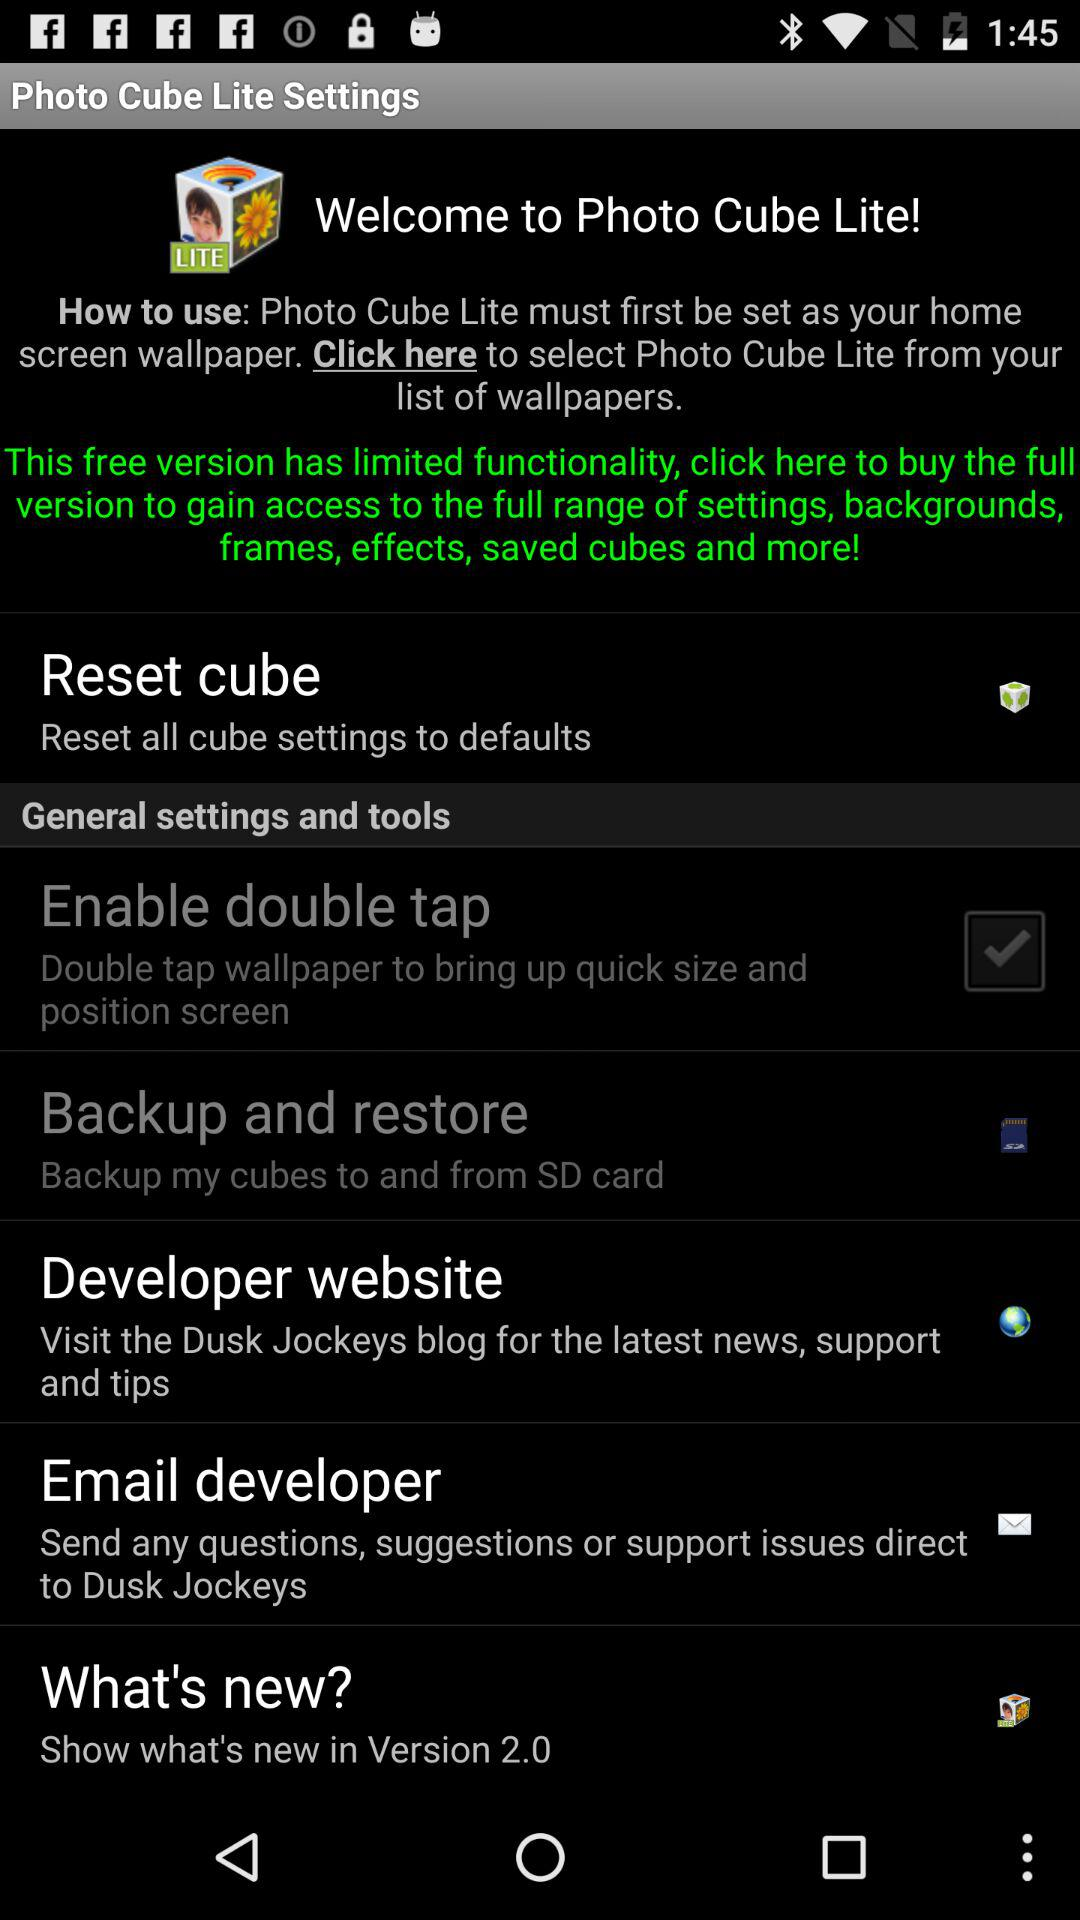What is the name of the application? The name of the application is "Photo Cube Lite". 